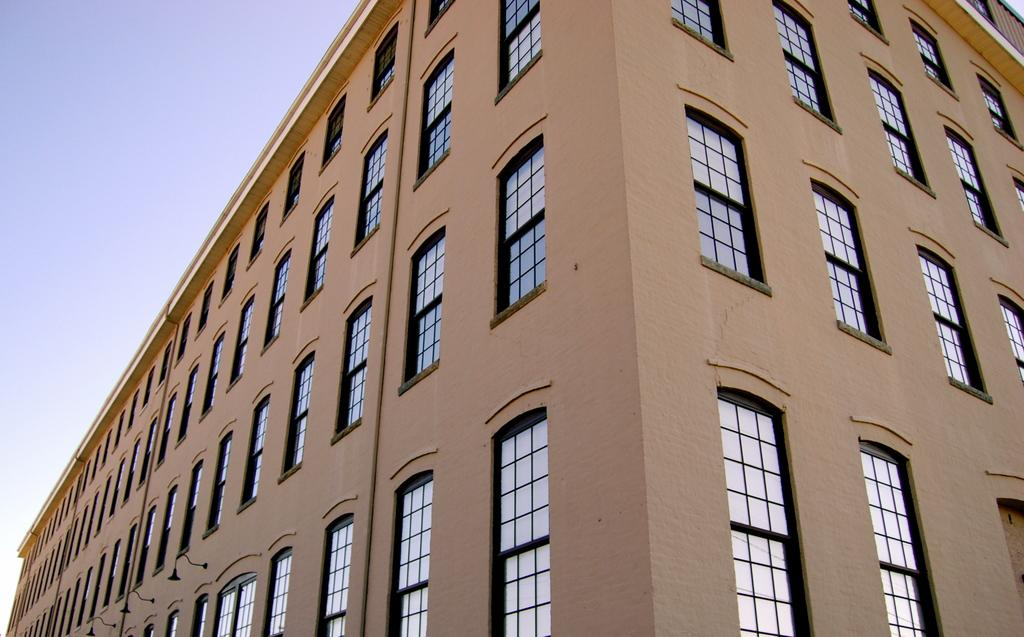What type of structure is present in the image? There is a building in the image. What are the main features of the building? The building has walls and glass windows. What can be seen in the background of the image? The sky is visible in the image. What type of creature is flying a kite in the rhythm of the wind in the image? There is no creature or kite present in the image; it only features a building with walls and glass windows, and the sky in the background. 